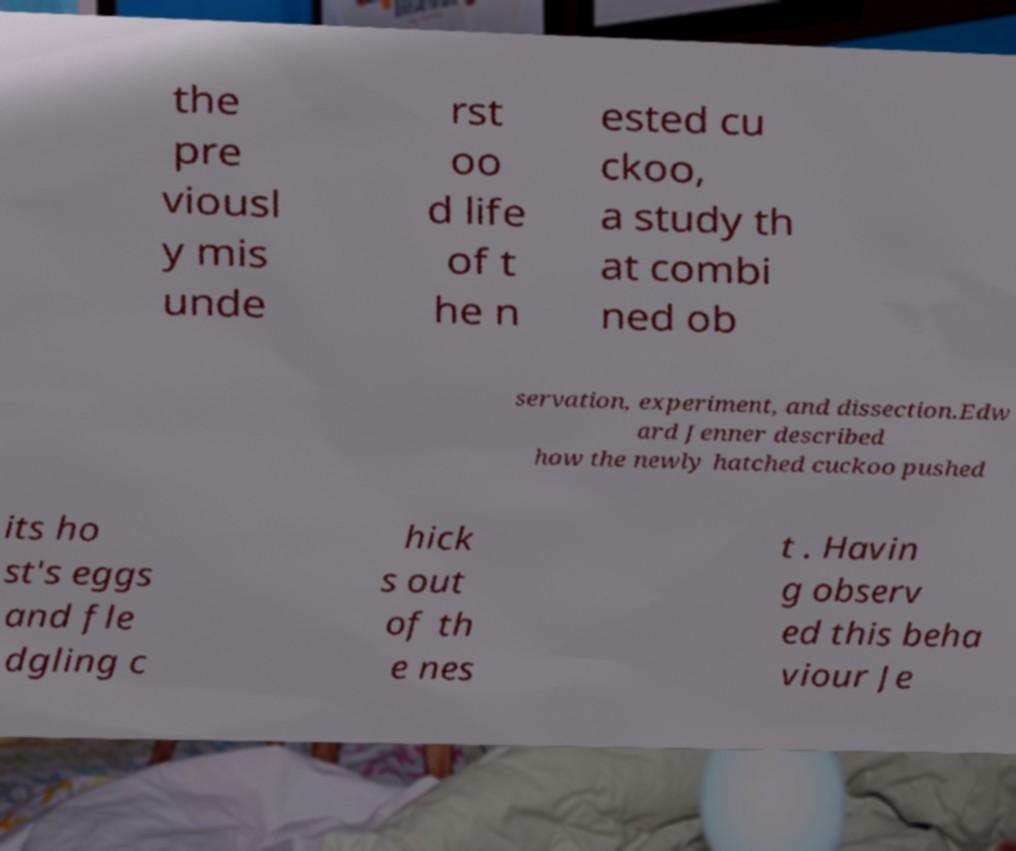Could you extract and type out the text from this image? the pre viousl y mis unde rst oo d life of t he n ested cu ckoo, a study th at combi ned ob servation, experiment, and dissection.Edw ard Jenner described how the newly hatched cuckoo pushed its ho st's eggs and fle dgling c hick s out of th e nes t . Havin g observ ed this beha viour Je 